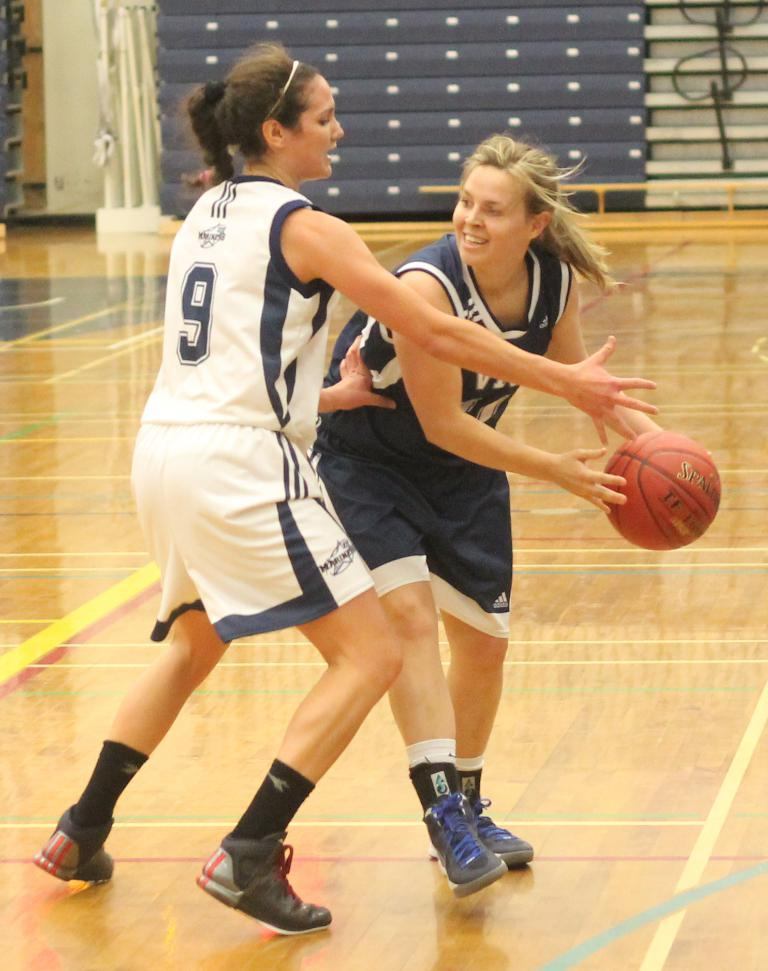<image>
Share a concise interpretation of the image provided. The number 9 player tries to block the girl on the other team. 